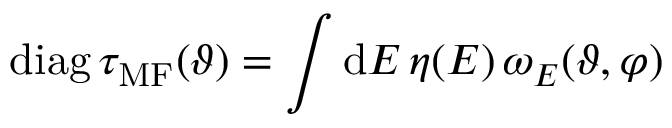<formula> <loc_0><loc_0><loc_500><loc_500>d i a g \, \tau _ { M F } ( \vartheta ) = \int d E \, \eta ( E ) \, \omega _ { E } ( \vartheta , \varphi )</formula> 